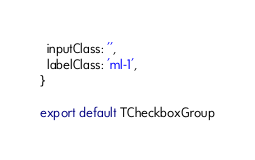<code> <loc_0><loc_0><loc_500><loc_500><_JavaScript_>  inputClass: '',
  labelClass: 'ml-1',
}

export default TCheckboxGroup
</code> 